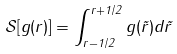<formula> <loc_0><loc_0><loc_500><loc_500>\mathcal { S } [ g ( r ) ] = \int _ { r - 1 / 2 } ^ { r + 1 / 2 } g ( \tilde { r } ) d \tilde { r }</formula> 